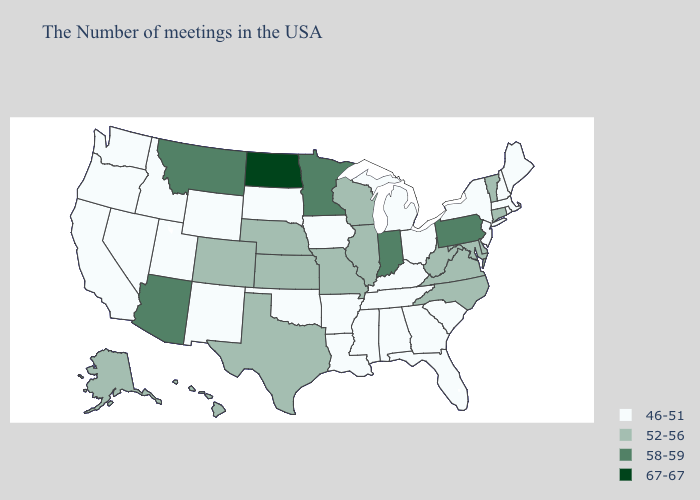Name the states that have a value in the range 58-59?
Keep it brief. Pennsylvania, Indiana, Minnesota, Montana, Arizona. Name the states that have a value in the range 58-59?
Answer briefly. Pennsylvania, Indiana, Minnesota, Montana, Arizona. Name the states that have a value in the range 58-59?
Answer briefly. Pennsylvania, Indiana, Minnesota, Montana, Arizona. Is the legend a continuous bar?
Concise answer only. No. What is the highest value in the USA?
Write a very short answer. 67-67. Name the states that have a value in the range 46-51?
Keep it brief. Maine, Massachusetts, Rhode Island, New Hampshire, New York, New Jersey, South Carolina, Ohio, Florida, Georgia, Michigan, Kentucky, Alabama, Tennessee, Mississippi, Louisiana, Arkansas, Iowa, Oklahoma, South Dakota, Wyoming, New Mexico, Utah, Idaho, Nevada, California, Washington, Oregon. What is the value of Massachusetts?
Keep it brief. 46-51. Name the states that have a value in the range 52-56?
Write a very short answer. Vermont, Connecticut, Delaware, Maryland, Virginia, North Carolina, West Virginia, Wisconsin, Illinois, Missouri, Kansas, Nebraska, Texas, Colorado, Alaska, Hawaii. What is the value of Connecticut?
Give a very brief answer. 52-56. Name the states that have a value in the range 46-51?
Be succinct. Maine, Massachusetts, Rhode Island, New Hampshire, New York, New Jersey, South Carolina, Ohio, Florida, Georgia, Michigan, Kentucky, Alabama, Tennessee, Mississippi, Louisiana, Arkansas, Iowa, Oklahoma, South Dakota, Wyoming, New Mexico, Utah, Idaho, Nevada, California, Washington, Oregon. What is the value of Indiana?
Short answer required. 58-59. Among the states that border New Hampshire , which have the lowest value?
Short answer required. Maine, Massachusetts. Does West Virginia have a higher value than North Carolina?
Be succinct. No. 